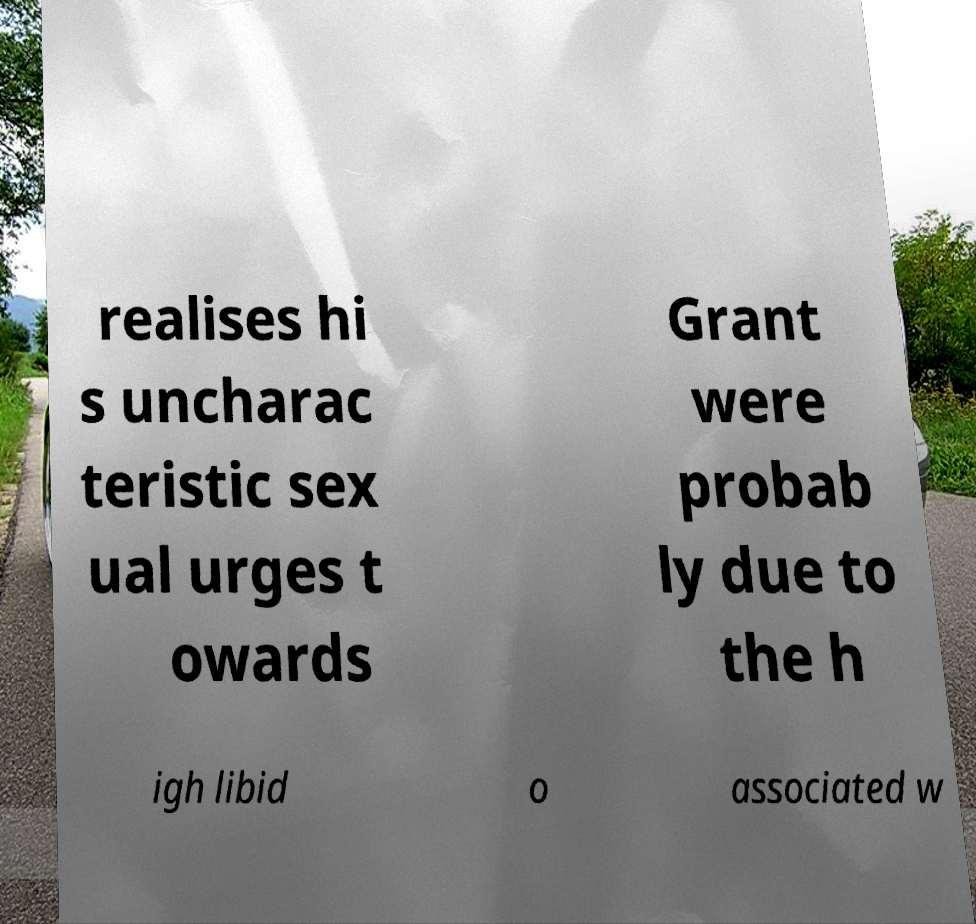Can you read and provide the text displayed in the image?This photo seems to have some interesting text. Can you extract and type it out for me? realises hi s uncharac teristic sex ual urges t owards Grant were probab ly due to the h igh libid o associated w 